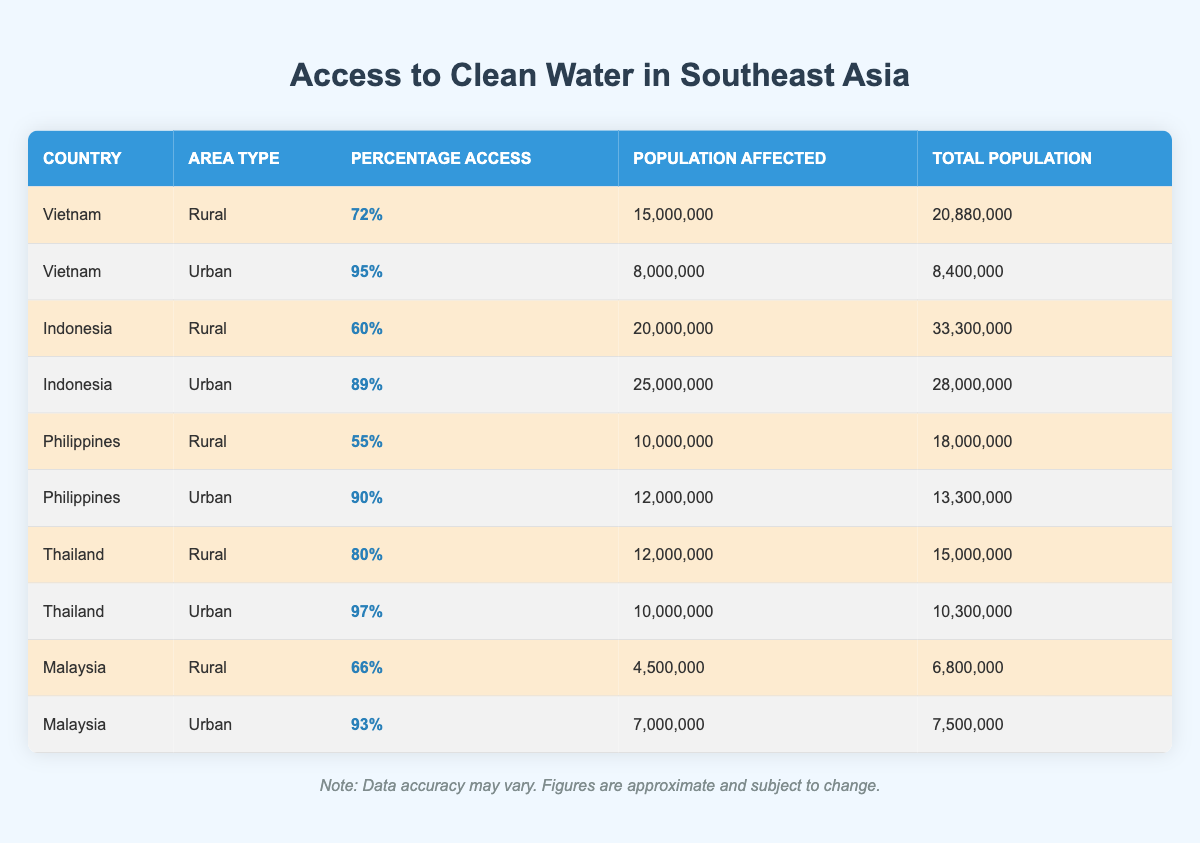What is the percentage access to clean water in urban areas of Vietnam? The table shows the specific data for Vietnam, and under the urban area type, the percentage access to clean water is listed as 95%.
Answer: 95% Which country has the lowest percentage of access to clean water in rural areas? By comparing the percentage access for rural areas across all countries, the Philippines has the lowest percentage at 55%.
Answer: Philippines What is the total population affected by lack of access to clean water in Indonesia? In the table, for Indonesia's rural area, the population affected is 20,000,000, and for urban, it's 25,000,000. Adding these gives a total of 20,000,000 + 25,000,000 = 45,000,000.
Answer: 45000000 Is the percentage of access to clean water higher in urban or rural areas across Southeast Asia? By comparing the highest percentages from both area types, urban areas have 95% for Vietnam and rural areas have 80% for Thailand. Therefore, urban areas have the higher access percentage overall.
Answer: Yes What is the average percentage access to clean water in rural areas of all listed countries? The rural percentages are 72% for Vietnam, 60% for Indonesia, 55% for the Philippines, 80% for Thailand, and 66% for Malaysia. Adding these gives a total of 72 + 60 + 55 + 80 + 66 = 333. There are 5 data points, thus the average is 333 / 5 = 66.6%.
Answer: 66.6% How many more people are affected by lack of access to clean water in the rural area compared to the urban area in Thailand? From the table, the rural population affected in Thailand is 12,000,000, and the urban area is 10,000,000. The difference is 12,000,000 - 10,000,000 = 2,000,000 more affected in the rural area.
Answer: 2000000 What country has the highest percentage access to clean water in urban areas? The table indicates that Vietnam has the highest percentage access in urban areas at 95%, compared to other urban figures.
Answer: Vietnam What percentage of the total population in rural areas of Vietnam has access to clean water? For rural areas, Vietnam has a total population of 20,880,000 and a percentage access of 72%. The number of people with access is 20,880,000 * 0.72 = 15,057,600. To find the percentage, (15,000,000 / 20,880,000) * 100 = 71.8%, which rounds to approximately 72%.
Answer: 72% 